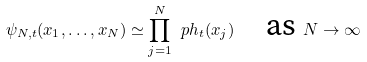<formula> <loc_0><loc_0><loc_500><loc_500>\psi _ { N , t } ( x _ { 1 } , \dots , x _ { N } ) \simeq \prod _ { j = 1 } ^ { N } \ p h _ { t } ( x _ { j } ) \quad \text {as } N \to \infty</formula> 